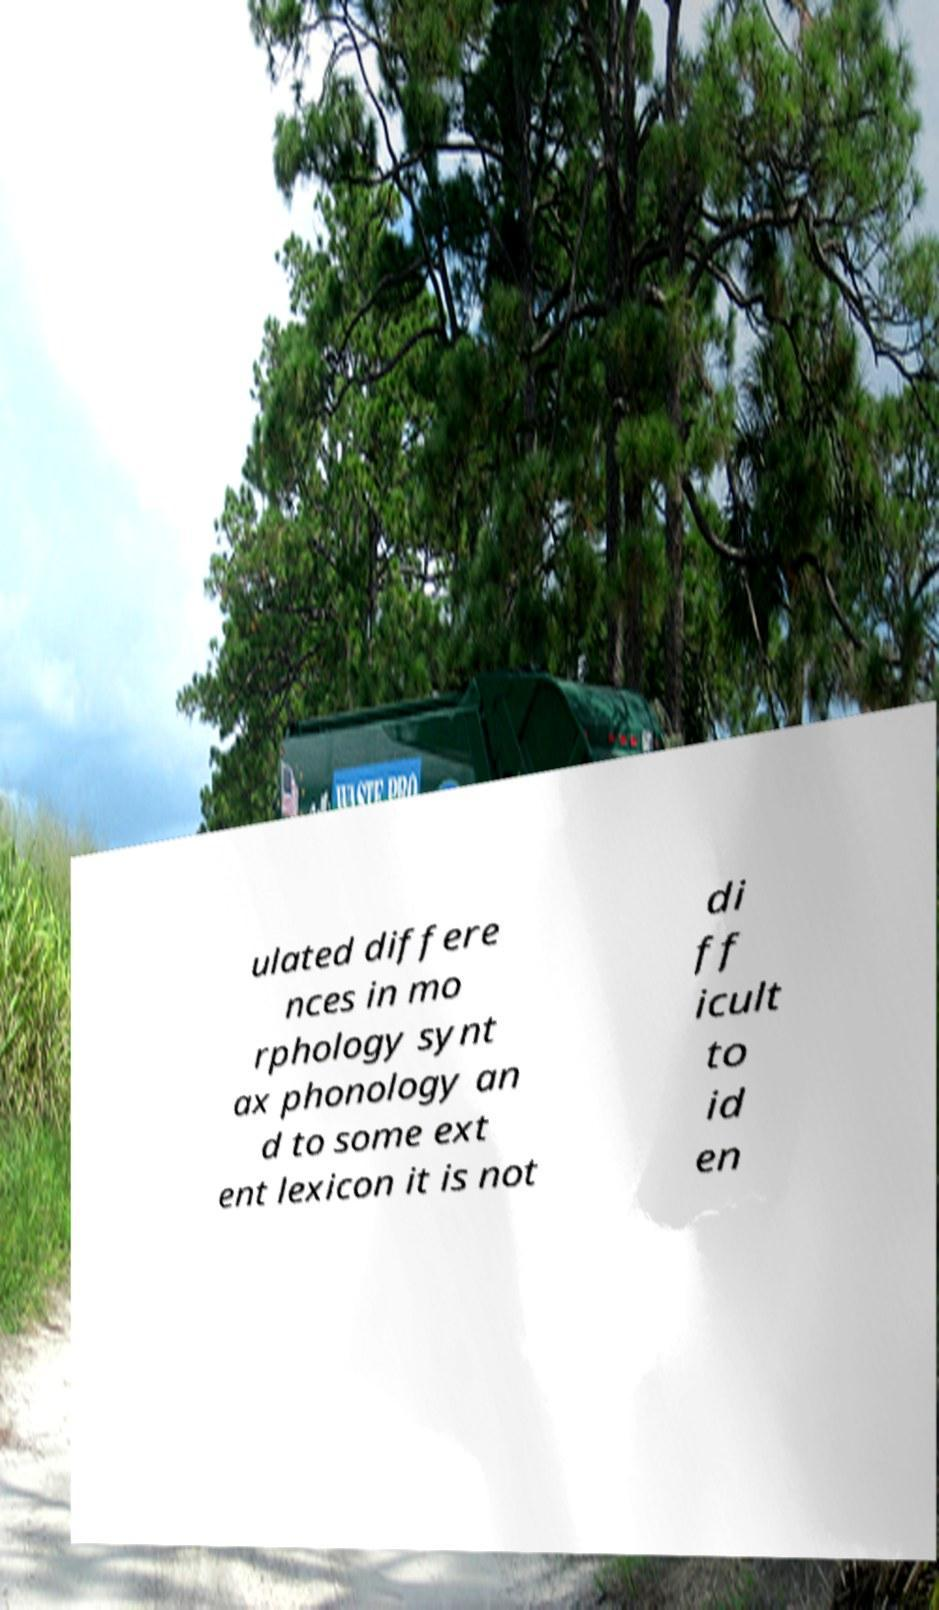Please identify and transcribe the text found in this image. ulated differe nces in mo rphology synt ax phonology an d to some ext ent lexicon it is not di ff icult to id en 